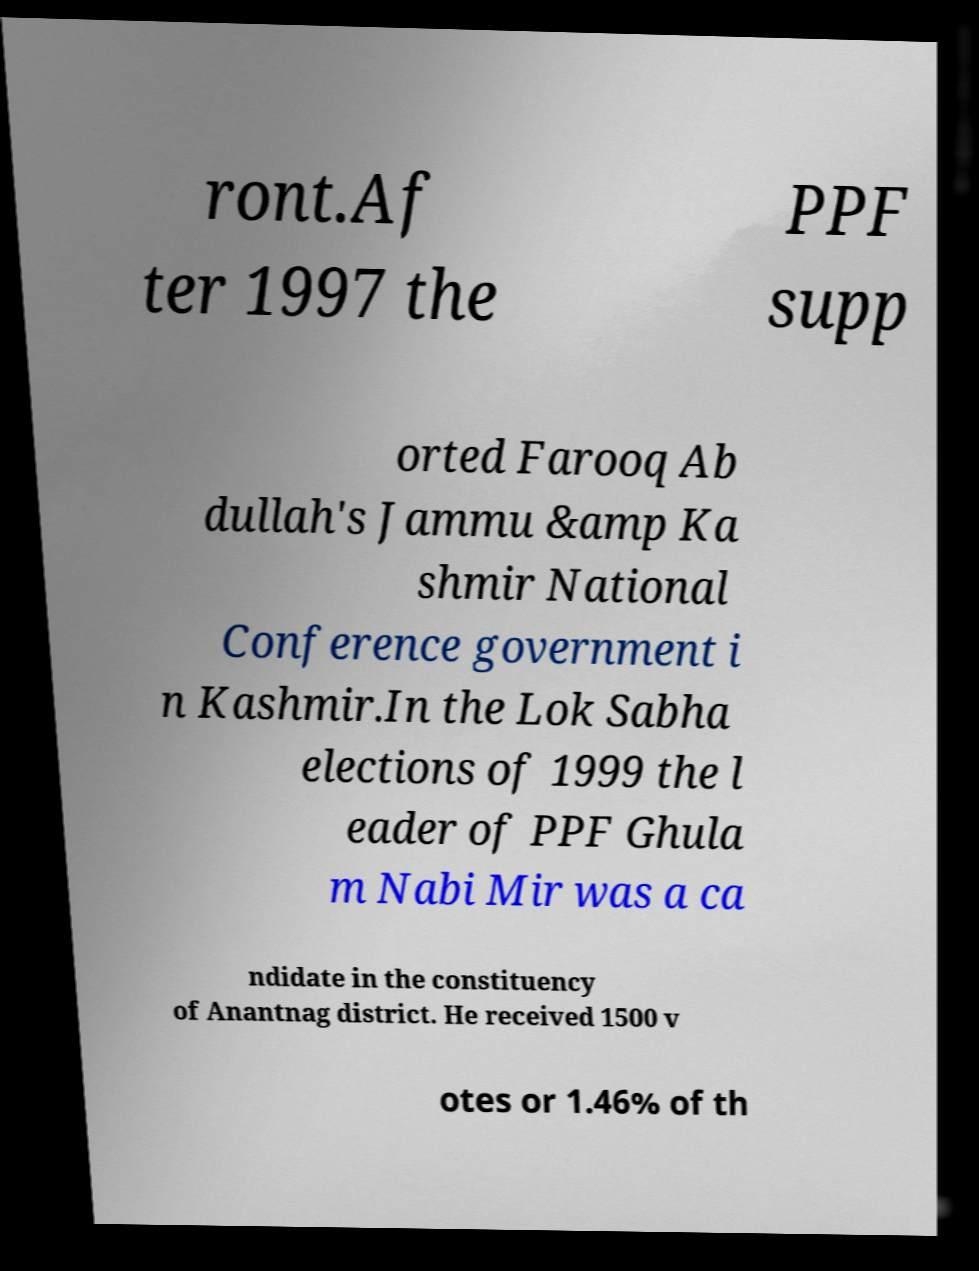Could you assist in decoding the text presented in this image and type it out clearly? ront.Af ter 1997 the PPF supp orted Farooq Ab dullah's Jammu &amp Ka shmir National Conference government i n Kashmir.In the Lok Sabha elections of 1999 the l eader of PPF Ghula m Nabi Mir was a ca ndidate in the constituency of Anantnag district. He received 1500 v otes or 1.46% of th 